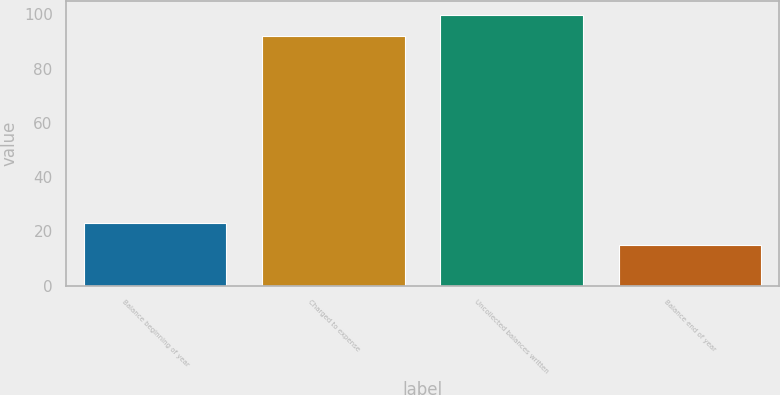<chart> <loc_0><loc_0><loc_500><loc_500><bar_chart><fcel>Balance beginning of year<fcel>Charged to expense<fcel>Uncollected balances written<fcel>Balance end of year<nl><fcel>22.9<fcel>92<fcel>99.9<fcel>15<nl></chart> 